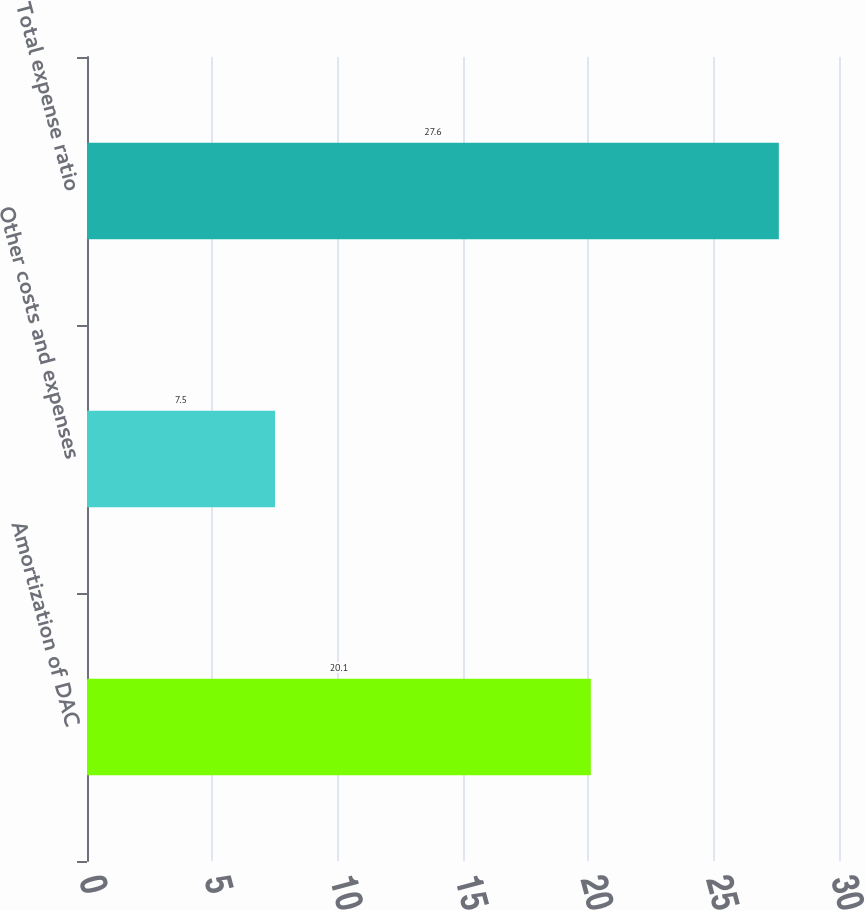Convert chart to OTSL. <chart><loc_0><loc_0><loc_500><loc_500><bar_chart><fcel>Amortization of DAC<fcel>Other costs and expenses<fcel>Total expense ratio<nl><fcel>20.1<fcel>7.5<fcel>27.6<nl></chart> 